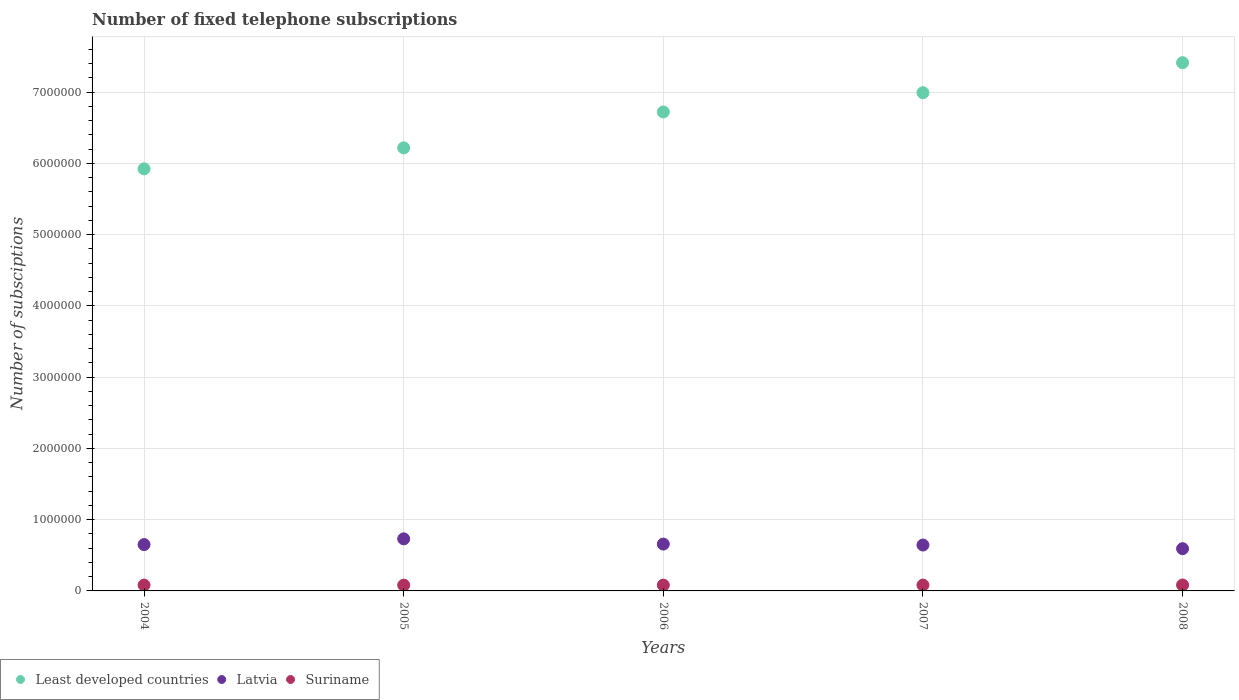How many different coloured dotlines are there?
Give a very brief answer. 3. Is the number of dotlines equal to the number of legend labels?
Your answer should be compact. Yes. What is the number of fixed telephone subscriptions in Latvia in 2007?
Your response must be concise. 6.44e+05. Across all years, what is the maximum number of fixed telephone subscriptions in Suriname?
Give a very brief answer. 8.30e+04. Across all years, what is the minimum number of fixed telephone subscriptions in Suriname?
Your answer should be very brief. 8.11e+04. In which year was the number of fixed telephone subscriptions in Latvia minimum?
Keep it short and to the point. 2008. What is the total number of fixed telephone subscriptions in Suriname in the graph?
Your response must be concise. 4.09e+05. What is the difference between the number of fixed telephone subscriptions in Latvia in 2005 and that in 2006?
Offer a terse response. 7.37e+04. What is the difference between the number of fixed telephone subscriptions in Least developed countries in 2004 and the number of fixed telephone subscriptions in Latvia in 2007?
Offer a very short reply. 5.28e+06. What is the average number of fixed telephone subscriptions in Latvia per year?
Provide a short and direct response. 6.55e+05. In the year 2007, what is the difference between the number of fixed telephone subscriptions in Suriname and number of fixed telephone subscriptions in Latvia?
Your answer should be compact. -5.62e+05. What is the ratio of the number of fixed telephone subscriptions in Least developed countries in 2004 to that in 2007?
Your answer should be compact. 0.85. Is the number of fixed telephone subscriptions in Least developed countries in 2005 less than that in 2007?
Your response must be concise. Yes. Is the difference between the number of fixed telephone subscriptions in Suriname in 2006 and 2007 greater than the difference between the number of fixed telephone subscriptions in Latvia in 2006 and 2007?
Your response must be concise. No. What is the difference between the highest and the second highest number of fixed telephone subscriptions in Least developed countries?
Keep it short and to the point. 4.21e+05. What is the difference between the highest and the lowest number of fixed telephone subscriptions in Least developed countries?
Your response must be concise. 1.49e+06. In how many years, is the number of fixed telephone subscriptions in Suriname greater than the average number of fixed telephone subscriptions in Suriname taken over all years?
Your answer should be compact. 2. Is the sum of the number of fixed telephone subscriptions in Least developed countries in 2005 and 2008 greater than the maximum number of fixed telephone subscriptions in Suriname across all years?
Your answer should be very brief. Yes. Is it the case that in every year, the sum of the number of fixed telephone subscriptions in Suriname and number of fixed telephone subscriptions in Least developed countries  is greater than the number of fixed telephone subscriptions in Latvia?
Make the answer very short. Yes. Is the number of fixed telephone subscriptions in Least developed countries strictly greater than the number of fixed telephone subscriptions in Suriname over the years?
Provide a succinct answer. Yes. How many dotlines are there?
Your response must be concise. 3. How many years are there in the graph?
Your answer should be very brief. 5. Are the values on the major ticks of Y-axis written in scientific E-notation?
Ensure brevity in your answer.  No. Does the graph contain any zero values?
Give a very brief answer. No. Does the graph contain grids?
Offer a terse response. Yes. How many legend labels are there?
Provide a short and direct response. 3. How are the legend labels stacked?
Give a very brief answer. Horizontal. What is the title of the graph?
Your response must be concise. Number of fixed telephone subscriptions. Does "Armenia" appear as one of the legend labels in the graph?
Ensure brevity in your answer.  No. What is the label or title of the Y-axis?
Give a very brief answer. Number of subsciptions. What is the Number of subsciptions of Least developed countries in 2004?
Offer a terse response. 5.92e+06. What is the Number of subsciptions of Latvia in 2004?
Give a very brief answer. 6.50e+05. What is the Number of subsciptions in Suriname in 2004?
Your answer should be very brief. 8.17e+04. What is the Number of subsciptions in Least developed countries in 2005?
Your answer should be very brief. 6.22e+06. What is the Number of subsciptions in Latvia in 2005?
Make the answer very short. 7.31e+05. What is the Number of subsciptions of Suriname in 2005?
Provide a succinct answer. 8.11e+04. What is the Number of subsciptions of Least developed countries in 2006?
Keep it short and to the point. 6.72e+06. What is the Number of subsciptions in Latvia in 2006?
Your answer should be very brief. 6.57e+05. What is the Number of subsciptions of Suriname in 2006?
Keep it short and to the point. 8.15e+04. What is the Number of subsciptions of Least developed countries in 2007?
Your answer should be very brief. 6.99e+06. What is the Number of subsciptions in Latvia in 2007?
Offer a very short reply. 6.44e+05. What is the Number of subsciptions in Suriname in 2007?
Your answer should be very brief. 8.20e+04. What is the Number of subsciptions of Least developed countries in 2008?
Provide a succinct answer. 7.41e+06. What is the Number of subsciptions in Latvia in 2008?
Give a very brief answer. 5.93e+05. What is the Number of subsciptions in Suriname in 2008?
Your answer should be very brief. 8.30e+04. Across all years, what is the maximum Number of subsciptions in Least developed countries?
Your answer should be very brief. 7.41e+06. Across all years, what is the maximum Number of subsciptions in Latvia?
Your response must be concise. 7.31e+05. Across all years, what is the maximum Number of subsciptions of Suriname?
Keep it short and to the point. 8.30e+04. Across all years, what is the minimum Number of subsciptions of Least developed countries?
Your answer should be compact. 5.92e+06. Across all years, what is the minimum Number of subsciptions in Latvia?
Offer a very short reply. 5.93e+05. Across all years, what is the minimum Number of subsciptions of Suriname?
Make the answer very short. 8.11e+04. What is the total Number of subsciptions of Least developed countries in the graph?
Give a very brief answer. 3.33e+07. What is the total Number of subsciptions in Latvia in the graph?
Give a very brief answer. 3.28e+06. What is the total Number of subsciptions of Suriname in the graph?
Give a very brief answer. 4.09e+05. What is the difference between the Number of subsciptions in Least developed countries in 2004 and that in 2005?
Offer a terse response. -2.94e+05. What is the difference between the Number of subsciptions of Latvia in 2004 and that in 2005?
Give a very brief answer. -8.06e+04. What is the difference between the Number of subsciptions in Suriname in 2004 and that in 2005?
Keep it short and to the point. 653. What is the difference between the Number of subsciptions of Least developed countries in 2004 and that in 2006?
Offer a very short reply. -7.98e+05. What is the difference between the Number of subsciptions of Latvia in 2004 and that in 2006?
Provide a succinct answer. -6925. What is the difference between the Number of subsciptions of Suriname in 2004 and that in 2006?
Provide a short and direct response. 209. What is the difference between the Number of subsciptions in Least developed countries in 2004 and that in 2007?
Your answer should be very brief. -1.07e+06. What is the difference between the Number of subsciptions of Latvia in 2004 and that in 2007?
Your answer should be very brief. 6412. What is the difference between the Number of subsciptions of Suriname in 2004 and that in 2007?
Give a very brief answer. -291. What is the difference between the Number of subsciptions of Least developed countries in 2004 and that in 2008?
Your answer should be very brief. -1.49e+06. What is the difference between the Number of subsciptions of Latvia in 2004 and that in 2008?
Offer a terse response. 5.76e+04. What is the difference between the Number of subsciptions in Suriname in 2004 and that in 2008?
Provide a short and direct response. -1291. What is the difference between the Number of subsciptions in Least developed countries in 2005 and that in 2006?
Keep it short and to the point. -5.04e+05. What is the difference between the Number of subsciptions in Latvia in 2005 and that in 2006?
Offer a very short reply. 7.37e+04. What is the difference between the Number of subsciptions in Suriname in 2005 and that in 2006?
Make the answer very short. -444. What is the difference between the Number of subsciptions in Least developed countries in 2005 and that in 2007?
Your answer should be very brief. -7.74e+05. What is the difference between the Number of subsciptions of Latvia in 2005 and that in 2007?
Your answer should be very brief. 8.71e+04. What is the difference between the Number of subsciptions in Suriname in 2005 and that in 2007?
Your answer should be compact. -944. What is the difference between the Number of subsciptions in Least developed countries in 2005 and that in 2008?
Offer a terse response. -1.20e+06. What is the difference between the Number of subsciptions of Latvia in 2005 and that in 2008?
Offer a terse response. 1.38e+05. What is the difference between the Number of subsciptions in Suriname in 2005 and that in 2008?
Give a very brief answer. -1944. What is the difference between the Number of subsciptions of Least developed countries in 2006 and that in 2007?
Offer a very short reply. -2.70e+05. What is the difference between the Number of subsciptions of Latvia in 2006 and that in 2007?
Ensure brevity in your answer.  1.33e+04. What is the difference between the Number of subsciptions in Suriname in 2006 and that in 2007?
Your response must be concise. -500. What is the difference between the Number of subsciptions of Least developed countries in 2006 and that in 2008?
Your answer should be compact. -6.92e+05. What is the difference between the Number of subsciptions in Latvia in 2006 and that in 2008?
Make the answer very short. 6.45e+04. What is the difference between the Number of subsciptions of Suriname in 2006 and that in 2008?
Provide a succinct answer. -1500. What is the difference between the Number of subsciptions in Least developed countries in 2007 and that in 2008?
Provide a succinct answer. -4.21e+05. What is the difference between the Number of subsciptions of Latvia in 2007 and that in 2008?
Your answer should be compact. 5.12e+04. What is the difference between the Number of subsciptions of Suriname in 2007 and that in 2008?
Provide a short and direct response. -1000. What is the difference between the Number of subsciptions of Least developed countries in 2004 and the Number of subsciptions of Latvia in 2005?
Offer a very short reply. 5.19e+06. What is the difference between the Number of subsciptions of Least developed countries in 2004 and the Number of subsciptions of Suriname in 2005?
Give a very brief answer. 5.84e+06. What is the difference between the Number of subsciptions of Latvia in 2004 and the Number of subsciptions of Suriname in 2005?
Offer a terse response. 5.69e+05. What is the difference between the Number of subsciptions in Least developed countries in 2004 and the Number of subsciptions in Latvia in 2006?
Your answer should be very brief. 5.27e+06. What is the difference between the Number of subsciptions in Least developed countries in 2004 and the Number of subsciptions in Suriname in 2006?
Make the answer very short. 5.84e+06. What is the difference between the Number of subsciptions in Latvia in 2004 and the Number of subsciptions in Suriname in 2006?
Your response must be concise. 5.69e+05. What is the difference between the Number of subsciptions of Least developed countries in 2004 and the Number of subsciptions of Latvia in 2007?
Provide a succinct answer. 5.28e+06. What is the difference between the Number of subsciptions of Least developed countries in 2004 and the Number of subsciptions of Suriname in 2007?
Make the answer very short. 5.84e+06. What is the difference between the Number of subsciptions in Latvia in 2004 and the Number of subsciptions in Suriname in 2007?
Provide a short and direct response. 5.68e+05. What is the difference between the Number of subsciptions in Least developed countries in 2004 and the Number of subsciptions in Latvia in 2008?
Provide a succinct answer. 5.33e+06. What is the difference between the Number of subsciptions of Least developed countries in 2004 and the Number of subsciptions of Suriname in 2008?
Provide a succinct answer. 5.84e+06. What is the difference between the Number of subsciptions of Latvia in 2004 and the Number of subsciptions of Suriname in 2008?
Provide a succinct answer. 5.67e+05. What is the difference between the Number of subsciptions in Least developed countries in 2005 and the Number of subsciptions in Latvia in 2006?
Offer a very short reply. 5.56e+06. What is the difference between the Number of subsciptions in Least developed countries in 2005 and the Number of subsciptions in Suriname in 2006?
Provide a short and direct response. 6.14e+06. What is the difference between the Number of subsciptions of Latvia in 2005 and the Number of subsciptions of Suriname in 2006?
Ensure brevity in your answer.  6.50e+05. What is the difference between the Number of subsciptions of Least developed countries in 2005 and the Number of subsciptions of Latvia in 2007?
Make the answer very short. 5.57e+06. What is the difference between the Number of subsciptions in Least developed countries in 2005 and the Number of subsciptions in Suriname in 2007?
Offer a terse response. 6.14e+06. What is the difference between the Number of subsciptions in Latvia in 2005 and the Number of subsciptions in Suriname in 2007?
Ensure brevity in your answer.  6.49e+05. What is the difference between the Number of subsciptions of Least developed countries in 2005 and the Number of subsciptions of Latvia in 2008?
Keep it short and to the point. 5.63e+06. What is the difference between the Number of subsciptions of Least developed countries in 2005 and the Number of subsciptions of Suriname in 2008?
Make the answer very short. 6.14e+06. What is the difference between the Number of subsciptions in Latvia in 2005 and the Number of subsciptions in Suriname in 2008?
Make the answer very short. 6.48e+05. What is the difference between the Number of subsciptions in Least developed countries in 2006 and the Number of subsciptions in Latvia in 2007?
Your answer should be very brief. 6.08e+06. What is the difference between the Number of subsciptions in Least developed countries in 2006 and the Number of subsciptions in Suriname in 2007?
Provide a short and direct response. 6.64e+06. What is the difference between the Number of subsciptions in Latvia in 2006 and the Number of subsciptions in Suriname in 2007?
Your answer should be very brief. 5.75e+05. What is the difference between the Number of subsciptions of Least developed countries in 2006 and the Number of subsciptions of Latvia in 2008?
Make the answer very short. 6.13e+06. What is the difference between the Number of subsciptions in Least developed countries in 2006 and the Number of subsciptions in Suriname in 2008?
Make the answer very short. 6.64e+06. What is the difference between the Number of subsciptions of Latvia in 2006 and the Number of subsciptions of Suriname in 2008?
Your answer should be compact. 5.74e+05. What is the difference between the Number of subsciptions in Least developed countries in 2007 and the Number of subsciptions in Latvia in 2008?
Offer a very short reply. 6.40e+06. What is the difference between the Number of subsciptions of Least developed countries in 2007 and the Number of subsciptions of Suriname in 2008?
Provide a succinct answer. 6.91e+06. What is the difference between the Number of subsciptions in Latvia in 2007 and the Number of subsciptions in Suriname in 2008?
Provide a short and direct response. 5.61e+05. What is the average Number of subsciptions in Least developed countries per year?
Keep it short and to the point. 6.65e+06. What is the average Number of subsciptions of Latvia per year?
Give a very brief answer. 6.55e+05. What is the average Number of subsciptions in Suriname per year?
Offer a terse response. 8.19e+04. In the year 2004, what is the difference between the Number of subsciptions of Least developed countries and Number of subsciptions of Latvia?
Your answer should be compact. 5.27e+06. In the year 2004, what is the difference between the Number of subsciptions in Least developed countries and Number of subsciptions in Suriname?
Keep it short and to the point. 5.84e+06. In the year 2004, what is the difference between the Number of subsciptions in Latvia and Number of subsciptions in Suriname?
Provide a short and direct response. 5.69e+05. In the year 2005, what is the difference between the Number of subsciptions of Least developed countries and Number of subsciptions of Latvia?
Your answer should be compact. 5.49e+06. In the year 2005, what is the difference between the Number of subsciptions in Least developed countries and Number of subsciptions in Suriname?
Your answer should be very brief. 6.14e+06. In the year 2005, what is the difference between the Number of subsciptions of Latvia and Number of subsciptions of Suriname?
Provide a short and direct response. 6.50e+05. In the year 2006, what is the difference between the Number of subsciptions of Least developed countries and Number of subsciptions of Latvia?
Ensure brevity in your answer.  6.06e+06. In the year 2006, what is the difference between the Number of subsciptions in Least developed countries and Number of subsciptions in Suriname?
Your answer should be compact. 6.64e+06. In the year 2006, what is the difference between the Number of subsciptions of Latvia and Number of subsciptions of Suriname?
Provide a succinct answer. 5.76e+05. In the year 2007, what is the difference between the Number of subsciptions of Least developed countries and Number of subsciptions of Latvia?
Make the answer very short. 6.35e+06. In the year 2007, what is the difference between the Number of subsciptions of Least developed countries and Number of subsciptions of Suriname?
Provide a short and direct response. 6.91e+06. In the year 2007, what is the difference between the Number of subsciptions of Latvia and Number of subsciptions of Suriname?
Offer a terse response. 5.62e+05. In the year 2008, what is the difference between the Number of subsciptions of Least developed countries and Number of subsciptions of Latvia?
Keep it short and to the point. 6.82e+06. In the year 2008, what is the difference between the Number of subsciptions in Least developed countries and Number of subsciptions in Suriname?
Give a very brief answer. 7.33e+06. In the year 2008, what is the difference between the Number of subsciptions of Latvia and Number of subsciptions of Suriname?
Your answer should be very brief. 5.10e+05. What is the ratio of the Number of subsciptions of Least developed countries in 2004 to that in 2005?
Make the answer very short. 0.95. What is the ratio of the Number of subsciptions of Latvia in 2004 to that in 2005?
Your answer should be compact. 0.89. What is the ratio of the Number of subsciptions of Least developed countries in 2004 to that in 2006?
Provide a short and direct response. 0.88. What is the ratio of the Number of subsciptions in Latvia in 2004 to that in 2006?
Offer a terse response. 0.99. What is the ratio of the Number of subsciptions of Suriname in 2004 to that in 2006?
Your response must be concise. 1. What is the ratio of the Number of subsciptions in Least developed countries in 2004 to that in 2007?
Provide a short and direct response. 0.85. What is the ratio of the Number of subsciptions of Suriname in 2004 to that in 2007?
Your response must be concise. 1. What is the ratio of the Number of subsciptions in Least developed countries in 2004 to that in 2008?
Your answer should be compact. 0.8. What is the ratio of the Number of subsciptions in Latvia in 2004 to that in 2008?
Your response must be concise. 1.1. What is the ratio of the Number of subsciptions of Suriname in 2004 to that in 2008?
Make the answer very short. 0.98. What is the ratio of the Number of subsciptions in Least developed countries in 2005 to that in 2006?
Make the answer very short. 0.93. What is the ratio of the Number of subsciptions in Latvia in 2005 to that in 2006?
Make the answer very short. 1.11. What is the ratio of the Number of subsciptions in Least developed countries in 2005 to that in 2007?
Make the answer very short. 0.89. What is the ratio of the Number of subsciptions of Latvia in 2005 to that in 2007?
Ensure brevity in your answer.  1.14. What is the ratio of the Number of subsciptions of Suriname in 2005 to that in 2007?
Offer a very short reply. 0.99. What is the ratio of the Number of subsciptions of Least developed countries in 2005 to that in 2008?
Provide a succinct answer. 0.84. What is the ratio of the Number of subsciptions of Latvia in 2005 to that in 2008?
Your response must be concise. 1.23. What is the ratio of the Number of subsciptions in Suriname in 2005 to that in 2008?
Provide a succinct answer. 0.98. What is the ratio of the Number of subsciptions in Least developed countries in 2006 to that in 2007?
Your answer should be very brief. 0.96. What is the ratio of the Number of subsciptions of Latvia in 2006 to that in 2007?
Ensure brevity in your answer.  1.02. What is the ratio of the Number of subsciptions of Suriname in 2006 to that in 2007?
Give a very brief answer. 0.99. What is the ratio of the Number of subsciptions of Least developed countries in 2006 to that in 2008?
Offer a terse response. 0.91. What is the ratio of the Number of subsciptions in Latvia in 2006 to that in 2008?
Your answer should be compact. 1.11. What is the ratio of the Number of subsciptions of Suriname in 2006 to that in 2008?
Your response must be concise. 0.98. What is the ratio of the Number of subsciptions of Least developed countries in 2007 to that in 2008?
Your answer should be compact. 0.94. What is the ratio of the Number of subsciptions of Latvia in 2007 to that in 2008?
Ensure brevity in your answer.  1.09. What is the ratio of the Number of subsciptions in Suriname in 2007 to that in 2008?
Offer a very short reply. 0.99. What is the difference between the highest and the second highest Number of subsciptions in Least developed countries?
Offer a terse response. 4.21e+05. What is the difference between the highest and the second highest Number of subsciptions of Latvia?
Make the answer very short. 7.37e+04. What is the difference between the highest and the second highest Number of subsciptions of Suriname?
Offer a terse response. 1000. What is the difference between the highest and the lowest Number of subsciptions of Least developed countries?
Provide a short and direct response. 1.49e+06. What is the difference between the highest and the lowest Number of subsciptions in Latvia?
Provide a short and direct response. 1.38e+05. What is the difference between the highest and the lowest Number of subsciptions of Suriname?
Your answer should be compact. 1944. 